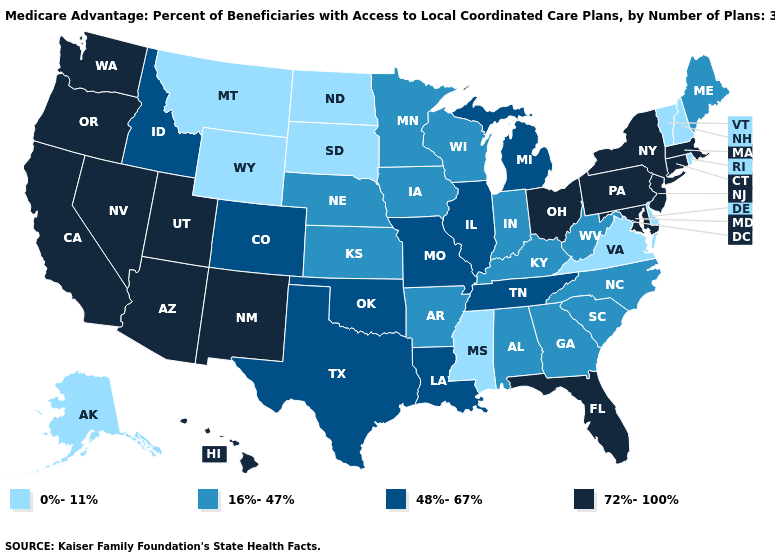What is the highest value in the South ?
Short answer required. 72%-100%. Name the states that have a value in the range 0%-11%?
Give a very brief answer. Alaska, Delaware, Mississippi, Montana, North Dakota, New Hampshire, Rhode Island, South Dakota, Virginia, Vermont, Wyoming. Among the states that border Oregon , which have the highest value?
Keep it brief. California, Nevada, Washington. Name the states that have a value in the range 72%-100%?
Quick response, please. Arizona, California, Connecticut, Florida, Hawaii, Massachusetts, Maryland, New Jersey, New Mexico, Nevada, New York, Ohio, Oregon, Pennsylvania, Utah, Washington. What is the value of Oregon?
Be succinct. 72%-100%. Does the first symbol in the legend represent the smallest category?
Keep it brief. Yes. Name the states that have a value in the range 48%-67%?
Answer briefly. Colorado, Idaho, Illinois, Louisiana, Michigan, Missouri, Oklahoma, Tennessee, Texas. What is the highest value in the USA?
Concise answer only. 72%-100%. Name the states that have a value in the range 0%-11%?
Answer briefly. Alaska, Delaware, Mississippi, Montana, North Dakota, New Hampshire, Rhode Island, South Dakota, Virginia, Vermont, Wyoming. Does Tennessee have the same value as California?
Short answer required. No. Which states have the highest value in the USA?
Give a very brief answer. Arizona, California, Connecticut, Florida, Hawaii, Massachusetts, Maryland, New Jersey, New Mexico, Nevada, New York, Ohio, Oregon, Pennsylvania, Utah, Washington. What is the value of New Hampshire?
Be succinct. 0%-11%. How many symbols are there in the legend?
Quick response, please. 4. Name the states that have a value in the range 0%-11%?
Be succinct. Alaska, Delaware, Mississippi, Montana, North Dakota, New Hampshire, Rhode Island, South Dakota, Virginia, Vermont, Wyoming. Name the states that have a value in the range 16%-47%?
Short answer required. Alabama, Arkansas, Georgia, Iowa, Indiana, Kansas, Kentucky, Maine, Minnesota, North Carolina, Nebraska, South Carolina, Wisconsin, West Virginia. 